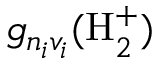<formula> <loc_0><loc_0><loc_500><loc_500>g _ { n _ { i } v _ { i } } ( H _ { 2 } ^ { + } )</formula> 